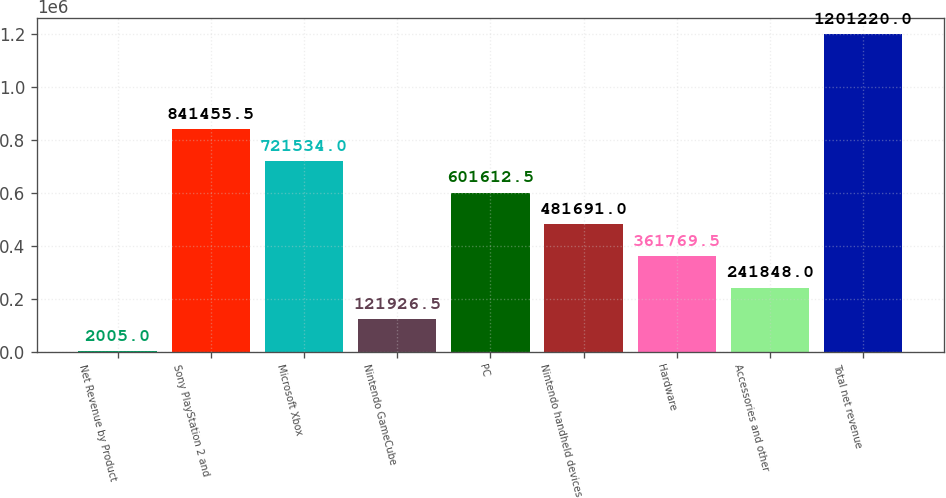Convert chart to OTSL. <chart><loc_0><loc_0><loc_500><loc_500><bar_chart><fcel>Net Revenue by Product<fcel>Sony PlayStation 2 and<fcel>Microsoft Xbox<fcel>Nintendo GameCube<fcel>PC<fcel>Nintendo handheld devices<fcel>Hardware<fcel>Accessories and other<fcel>Total net revenue<nl><fcel>2005<fcel>841456<fcel>721534<fcel>121926<fcel>601612<fcel>481691<fcel>361770<fcel>241848<fcel>1.20122e+06<nl></chart> 